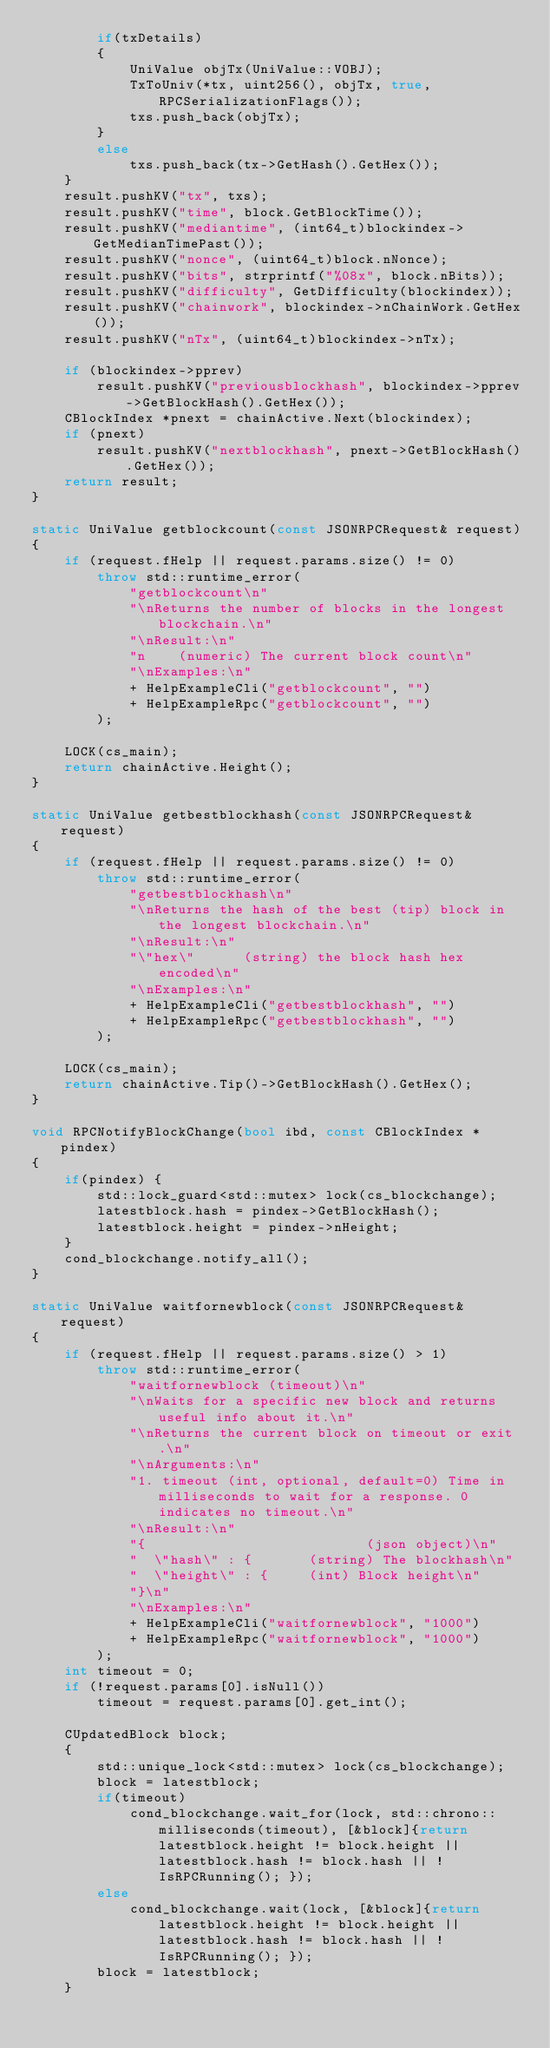Convert code to text. <code><loc_0><loc_0><loc_500><loc_500><_C++_>        if(txDetails)
        {
            UniValue objTx(UniValue::VOBJ);
            TxToUniv(*tx, uint256(), objTx, true, RPCSerializationFlags());
            txs.push_back(objTx);
        }
        else
            txs.push_back(tx->GetHash().GetHex());
    }
    result.pushKV("tx", txs);
    result.pushKV("time", block.GetBlockTime());
    result.pushKV("mediantime", (int64_t)blockindex->GetMedianTimePast());
    result.pushKV("nonce", (uint64_t)block.nNonce);
    result.pushKV("bits", strprintf("%08x", block.nBits));
    result.pushKV("difficulty", GetDifficulty(blockindex));
    result.pushKV("chainwork", blockindex->nChainWork.GetHex());
    result.pushKV("nTx", (uint64_t)blockindex->nTx);

    if (blockindex->pprev)
        result.pushKV("previousblockhash", blockindex->pprev->GetBlockHash().GetHex());
    CBlockIndex *pnext = chainActive.Next(blockindex);
    if (pnext)
        result.pushKV("nextblockhash", pnext->GetBlockHash().GetHex());
    return result;
}

static UniValue getblockcount(const JSONRPCRequest& request)
{
    if (request.fHelp || request.params.size() != 0)
        throw std::runtime_error(
            "getblockcount\n"
            "\nReturns the number of blocks in the longest blockchain.\n"
            "\nResult:\n"
            "n    (numeric) The current block count\n"
            "\nExamples:\n"
            + HelpExampleCli("getblockcount", "")
            + HelpExampleRpc("getblockcount", "")
        );

    LOCK(cs_main);
    return chainActive.Height();
}

static UniValue getbestblockhash(const JSONRPCRequest& request)
{
    if (request.fHelp || request.params.size() != 0)
        throw std::runtime_error(
            "getbestblockhash\n"
            "\nReturns the hash of the best (tip) block in the longest blockchain.\n"
            "\nResult:\n"
            "\"hex\"      (string) the block hash hex encoded\n"
            "\nExamples:\n"
            + HelpExampleCli("getbestblockhash", "")
            + HelpExampleRpc("getbestblockhash", "")
        );

    LOCK(cs_main);
    return chainActive.Tip()->GetBlockHash().GetHex();
}

void RPCNotifyBlockChange(bool ibd, const CBlockIndex * pindex)
{
    if(pindex) {
        std::lock_guard<std::mutex> lock(cs_blockchange);
        latestblock.hash = pindex->GetBlockHash();
        latestblock.height = pindex->nHeight;
    }
    cond_blockchange.notify_all();
}

static UniValue waitfornewblock(const JSONRPCRequest& request)
{
    if (request.fHelp || request.params.size() > 1)
        throw std::runtime_error(
            "waitfornewblock (timeout)\n"
            "\nWaits for a specific new block and returns useful info about it.\n"
            "\nReturns the current block on timeout or exit.\n"
            "\nArguments:\n"
            "1. timeout (int, optional, default=0) Time in milliseconds to wait for a response. 0 indicates no timeout.\n"
            "\nResult:\n"
            "{                           (json object)\n"
            "  \"hash\" : {       (string) The blockhash\n"
            "  \"height\" : {     (int) Block height\n"
            "}\n"
            "\nExamples:\n"
            + HelpExampleCli("waitfornewblock", "1000")
            + HelpExampleRpc("waitfornewblock", "1000")
        );
    int timeout = 0;
    if (!request.params[0].isNull())
        timeout = request.params[0].get_int();

    CUpdatedBlock block;
    {
        std::unique_lock<std::mutex> lock(cs_blockchange);
        block = latestblock;
        if(timeout)
            cond_blockchange.wait_for(lock, std::chrono::milliseconds(timeout), [&block]{return latestblock.height != block.height || latestblock.hash != block.hash || !IsRPCRunning(); });
        else
            cond_blockchange.wait(lock, [&block]{return latestblock.height != block.height || latestblock.hash != block.hash || !IsRPCRunning(); });
        block = latestblock;
    }</code> 